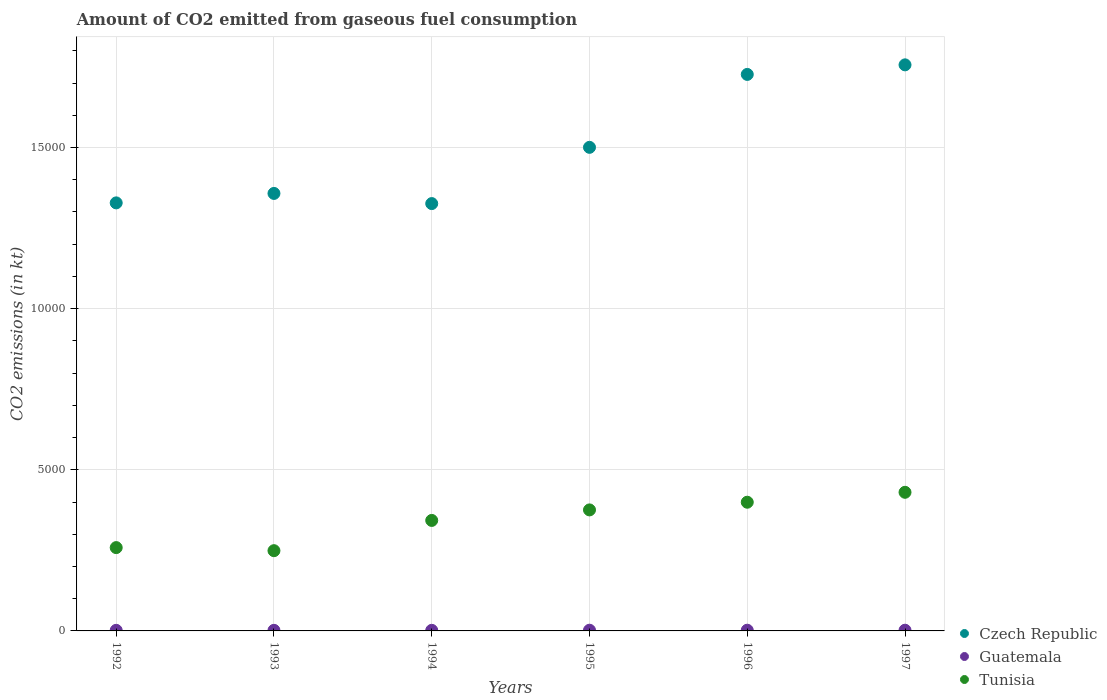How many different coloured dotlines are there?
Give a very brief answer. 3. Is the number of dotlines equal to the number of legend labels?
Your answer should be compact. Yes. What is the amount of CO2 emitted in Czech Republic in 1997?
Give a very brief answer. 1.76e+04. Across all years, what is the maximum amount of CO2 emitted in Guatemala?
Make the answer very short. 22. Across all years, what is the minimum amount of CO2 emitted in Tunisia?
Offer a very short reply. 2489.89. In which year was the amount of CO2 emitted in Czech Republic maximum?
Provide a short and direct response. 1997. In which year was the amount of CO2 emitted in Tunisia minimum?
Keep it short and to the point. 1993. What is the total amount of CO2 emitted in Guatemala in the graph?
Provide a short and direct response. 121.01. What is the difference between the amount of CO2 emitted in Guatemala in 1992 and that in 1995?
Provide a succinct answer. -3.67. What is the difference between the amount of CO2 emitted in Guatemala in 1994 and the amount of CO2 emitted in Czech Republic in 1996?
Offer a very short reply. -1.72e+04. What is the average amount of CO2 emitted in Tunisia per year?
Ensure brevity in your answer.  3425.59. In the year 1995, what is the difference between the amount of CO2 emitted in Guatemala and amount of CO2 emitted in Tunisia?
Provide a short and direct response. -3733.01. What is the ratio of the amount of CO2 emitted in Guatemala in 1992 to that in 1994?
Provide a succinct answer. 1. What is the difference between the highest and the second highest amount of CO2 emitted in Czech Republic?
Provide a short and direct response. 297.03. What is the difference between the highest and the lowest amount of CO2 emitted in Guatemala?
Keep it short and to the point. 3.67. In how many years, is the amount of CO2 emitted in Czech Republic greater than the average amount of CO2 emitted in Czech Republic taken over all years?
Provide a succinct answer. 3. Is it the case that in every year, the sum of the amount of CO2 emitted in Tunisia and amount of CO2 emitted in Guatemala  is greater than the amount of CO2 emitted in Czech Republic?
Your answer should be very brief. No. How many dotlines are there?
Your response must be concise. 3. Does the graph contain grids?
Your response must be concise. Yes. Where does the legend appear in the graph?
Provide a short and direct response. Bottom right. How are the legend labels stacked?
Keep it short and to the point. Vertical. What is the title of the graph?
Provide a short and direct response. Amount of CO2 emitted from gaseous fuel consumption. Does "Thailand" appear as one of the legend labels in the graph?
Your answer should be very brief. No. What is the label or title of the X-axis?
Ensure brevity in your answer.  Years. What is the label or title of the Y-axis?
Make the answer very short. CO2 emissions (in kt). What is the CO2 emissions (in kt) of Czech Republic in 1992?
Offer a terse response. 1.33e+04. What is the CO2 emissions (in kt) of Guatemala in 1992?
Give a very brief answer. 18.34. What is the CO2 emissions (in kt) in Tunisia in 1992?
Your answer should be compact. 2585.24. What is the CO2 emissions (in kt) in Czech Republic in 1993?
Your answer should be compact. 1.36e+04. What is the CO2 emissions (in kt) of Guatemala in 1993?
Give a very brief answer. 18.34. What is the CO2 emissions (in kt) of Tunisia in 1993?
Give a very brief answer. 2489.89. What is the CO2 emissions (in kt) of Czech Republic in 1994?
Your answer should be compact. 1.33e+04. What is the CO2 emissions (in kt) of Guatemala in 1994?
Your answer should be compact. 18.34. What is the CO2 emissions (in kt) of Tunisia in 1994?
Provide a succinct answer. 3428.64. What is the CO2 emissions (in kt) of Czech Republic in 1995?
Your answer should be very brief. 1.50e+04. What is the CO2 emissions (in kt) of Guatemala in 1995?
Provide a short and direct response. 22. What is the CO2 emissions (in kt) in Tunisia in 1995?
Provide a short and direct response. 3755.01. What is the CO2 emissions (in kt) in Czech Republic in 1996?
Provide a succinct answer. 1.73e+04. What is the CO2 emissions (in kt) in Guatemala in 1996?
Make the answer very short. 22. What is the CO2 emissions (in kt) of Tunisia in 1996?
Your answer should be very brief. 3993.36. What is the CO2 emissions (in kt) of Czech Republic in 1997?
Provide a succinct answer. 1.76e+04. What is the CO2 emissions (in kt) in Guatemala in 1997?
Provide a short and direct response. 22. What is the CO2 emissions (in kt) in Tunisia in 1997?
Provide a succinct answer. 4301.39. Across all years, what is the maximum CO2 emissions (in kt) in Czech Republic?
Provide a succinct answer. 1.76e+04. Across all years, what is the maximum CO2 emissions (in kt) in Guatemala?
Offer a very short reply. 22. Across all years, what is the maximum CO2 emissions (in kt) in Tunisia?
Provide a succinct answer. 4301.39. Across all years, what is the minimum CO2 emissions (in kt) in Czech Republic?
Your answer should be compact. 1.33e+04. Across all years, what is the minimum CO2 emissions (in kt) in Guatemala?
Make the answer very short. 18.34. Across all years, what is the minimum CO2 emissions (in kt) of Tunisia?
Your response must be concise. 2489.89. What is the total CO2 emissions (in kt) in Czech Republic in the graph?
Provide a succinct answer. 9.00e+04. What is the total CO2 emissions (in kt) in Guatemala in the graph?
Keep it short and to the point. 121.01. What is the total CO2 emissions (in kt) of Tunisia in the graph?
Ensure brevity in your answer.  2.06e+04. What is the difference between the CO2 emissions (in kt) of Czech Republic in 1992 and that in 1993?
Your response must be concise. -293.36. What is the difference between the CO2 emissions (in kt) of Guatemala in 1992 and that in 1993?
Offer a terse response. 0. What is the difference between the CO2 emissions (in kt) in Tunisia in 1992 and that in 1993?
Offer a terse response. 95.34. What is the difference between the CO2 emissions (in kt) in Czech Republic in 1992 and that in 1994?
Provide a succinct answer. 22. What is the difference between the CO2 emissions (in kt) of Guatemala in 1992 and that in 1994?
Provide a short and direct response. 0. What is the difference between the CO2 emissions (in kt) of Tunisia in 1992 and that in 1994?
Make the answer very short. -843.41. What is the difference between the CO2 emissions (in kt) in Czech Republic in 1992 and that in 1995?
Your answer should be compact. -1723.49. What is the difference between the CO2 emissions (in kt) in Guatemala in 1992 and that in 1995?
Offer a very short reply. -3.67. What is the difference between the CO2 emissions (in kt) in Tunisia in 1992 and that in 1995?
Provide a short and direct response. -1169.77. What is the difference between the CO2 emissions (in kt) in Czech Republic in 1992 and that in 1996?
Keep it short and to the point. -3986.03. What is the difference between the CO2 emissions (in kt) of Guatemala in 1992 and that in 1996?
Provide a short and direct response. -3.67. What is the difference between the CO2 emissions (in kt) of Tunisia in 1992 and that in 1996?
Your answer should be compact. -1408.13. What is the difference between the CO2 emissions (in kt) of Czech Republic in 1992 and that in 1997?
Offer a very short reply. -4283.06. What is the difference between the CO2 emissions (in kt) of Guatemala in 1992 and that in 1997?
Make the answer very short. -3.67. What is the difference between the CO2 emissions (in kt) in Tunisia in 1992 and that in 1997?
Ensure brevity in your answer.  -1716.16. What is the difference between the CO2 emissions (in kt) of Czech Republic in 1993 and that in 1994?
Offer a very short reply. 315.36. What is the difference between the CO2 emissions (in kt) of Tunisia in 1993 and that in 1994?
Provide a succinct answer. -938.75. What is the difference between the CO2 emissions (in kt) in Czech Republic in 1993 and that in 1995?
Provide a short and direct response. -1430.13. What is the difference between the CO2 emissions (in kt) in Guatemala in 1993 and that in 1995?
Make the answer very short. -3.67. What is the difference between the CO2 emissions (in kt) in Tunisia in 1993 and that in 1995?
Your response must be concise. -1265.12. What is the difference between the CO2 emissions (in kt) of Czech Republic in 1993 and that in 1996?
Offer a terse response. -3692.67. What is the difference between the CO2 emissions (in kt) of Guatemala in 1993 and that in 1996?
Your answer should be compact. -3.67. What is the difference between the CO2 emissions (in kt) in Tunisia in 1993 and that in 1996?
Your answer should be very brief. -1503.47. What is the difference between the CO2 emissions (in kt) in Czech Republic in 1993 and that in 1997?
Provide a short and direct response. -3989.7. What is the difference between the CO2 emissions (in kt) of Guatemala in 1993 and that in 1997?
Ensure brevity in your answer.  -3.67. What is the difference between the CO2 emissions (in kt) of Tunisia in 1993 and that in 1997?
Keep it short and to the point. -1811.5. What is the difference between the CO2 emissions (in kt) in Czech Republic in 1994 and that in 1995?
Your answer should be compact. -1745.49. What is the difference between the CO2 emissions (in kt) in Guatemala in 1994 and that in 1995?
Keep it short and to the point. -3.67. What is the difference between the CO2 emissions (in kt) of Tunisia in 1994 and that in 1995?
Offer a very short reply. -326.36. What is the difference between the CO2 emissions (in kt) of Czech Republic in 1994 and that in 1996?
Your response must be concise. -4008.03. What is the difference between the CO2 emissions (in kt) in Guatemala in 1994 and that in 1996?
Keep it short and to the point. -3.67. What is the difference between the CO2 emissions (in kt) of Tunisia in 1994 and that in 1996?
Provide a succinct answer. -564.72. What is the difference between the CO2 emissions (in kt) of Czech Republic in 1994 and that in 1997?
Provide a succinct answer. -4305.06. What is the difference between the CO2 emissions (in kt) of Guatemala in 1994 and that in 1997?
Offer a terse response. -3.67. What is the difference between the CO2 emissions (in kt) in Tunisia in 1994 and that in 1997?
Make the answer very short. -872.75. What is the difference between the CO2 emissions (in kt) of Czech Republic in 1995 and that in 1996?
Your answer should be very brief. -2262.54. What is the difference between the CO2 emissions (in kt) of Tunisia in 1995 and that in 1996?
Your response must be concise. -238.35. What is the difference between the CO2 emissions (in kt) of Czech Republic in 1995 and that in 1997?
Your answer should be very brief. -2559.57. What is the difference between the CO2 emissions (in kt) in Tunisia in 1995 and that in 1997?
Ensure brevity in your answer.  -546.38. What is the difference between the CO2 emissions (in kt) in Czech Republic in 1996 and that in 1997?
Make the answer very short. -297.03. What is the difference between the CO2 emissions (in kt) in Tunisia in 1996 and that in 1997?
Your response must be concise. -308.03. What is the difference between the CO2 emissions (in kt) in Czech Republic in 1992 and the CO2 emissions (in kt) in Guatemala in 1993?
Provide a succinct answer. 1.33e+04. What is the difference between the CO2 emissions (in kt) in Czech Republic in 1992 and the CO2 emissions (in kt) in Tunisia in 1993?
Provide a succinct answer. 1.08e+04. What is the difference between the CO2 emissions (in kt) in Guatemala in 1992 and the CO2 emissions (in kt) in Tunisia in 1993?
Your answer should be compact. -2471.56. What is the difference between the CO2 emissions (in kt) in Czech Republic in 1992 and the CO2 emissions (in kt) in Guatemala in 1994?
Give a very brief answer. 1.33e+04. What is the difference between the CO2 emissions (in kt) of Czech Republic in 1992 and the CO2 emissions (in kt) of Tunisia in 1994?
Keep it short and to the point. 9853.23. What is the difference between the CO2 emissions (in kt) in Guatemala in 1992 and the CO2 emissions (in kt) in Tunisia in 1994?
Your answer should be very brief. -3410.31. What is the difference between the CO2 emissions (in kt) of Czech Republic in 1992 and the CO2 emissions (in kt) of Guatemala in 1995?
Offer a terse response. 1.33e+04. What is the difference between the CO2 emissions (in kt) of Czech Republic in 1992 and the CO2 emissions (in kt) of Tunisia in 1995?
Provide a short and direct response. 9526.87. What is the difference between the CO2 emissions (in kt) in Guatemala in 1992 and the CO2 emissions (in kt) in Tunisia in 1995?
Provide a succinct answer. -3736.67. What is the difference between the CO2 emissions (in kt) of Czech Republic in 1992 and the CO2 emissions (in kt) of Guatemala in 1996?
Ensure brevity in your answer.  1.33e+04. What is the difference between the CO2 emissions (in kt) in Czech Republic in 1992 and the CO2 emissions (in kt) in Tunisia in 1996?
Your answer should be compact. 9288.51. What is the difference between the CO2 emissions (in kt) in Guatemala in 1992 and the CO2 emissions (in kt) in Tunisia in 1996?
Your answer should be compact. -3975.03. What is the difference between the CO2 emissions (in kt) in Czech Republic in 1992 and the CO2 emissions (in kt) in Guatemala in 1997?
Provide a short and direct response. 1.33e+04. What is the difference between the CO2 emissions (in kt) in Czech Republic in 1992 and the CO2 emissions (in kt) in Tunisia in 1997?
Your answer should be compact. 8980.48. What is the difference between the CO2 emissions (in kt) of Guatemala in 1992 and the CO2 emissions (in kt) of Tunisia in 1997?
Your answer should be compact. -4283.06. What is the difference between the CO2 emissions (in kt) in Czech Republic in 1993 and the CO2 emissions (in kt) in Guatemala in 1994?
Make the answer very short. 1.36e+04. What is the difference between the CO2 emissions (in kt) of Czech Republic in 1993 and the CO2 emissions (in kt) of Tunisia in 1994?
Offer a very short reply. 1.01e+04. What is the difference between the CO2 emissions (in kt) in Guatemala in 1993 and the CO2 emissions (in kt) in Tunisia in 1994?
Offer a terse response. -3410.31. What is the difference between the CO2 emissions (in kt) of Czech Republic in 1993 and the CO2 emissions (in kt) of Guatemala in 1995?
Provide a short and direct response. 1.36e+04. What is the difference between the CO2 emissions (in kt) in Czech Republic in 1993 and the CO2 emissions (in kt) in Tunisia in 1995?
Ensure brevity in your answer.  9820.23. What is the difference between the CO2 emissions (in kt) in Guatemala in 1993 and the CO2 emissions (in kt) in Tunisia in 1995?
Give a very brief answer. -3736.67. What is the difference between the CO2 emissions (in kt) of Czech Republic in 1993 and the CO2 emissions (in kt) of Guatemala in 1996?
Your answer should be very brief. 1.36e+04. What is the difference between the CO2 emissions (in kt) of Czech Republic in 1993 and the CO2 emissions (in kt) of Tunisia in 1996?
Make the answer very short. 9581.87. What is the difference between the CO2 emissions (in kt) of Guatemala in 1993 and the CO2 emissions (in kt) of Tunisia in 1996?
Ensure brevity in your answer.  -3975.03. What is the difference between the CO2 emissions (in kt) of Czech Republic in 1993 and the CO2 emissions (in kt) of Guatemala in 1997?
Keep it short and to the point. 1.36e+04. What is the difference between the CO2 emissions (in kt) of Czech Republic in 1993 and the CO2 emissions (in kt) of Tunisia in 1997?
Keep it short and to the point. 9273.84. What is the difference between the CO2 emissions (in kt) in Guatemala in 1993 and the CO2 emissions (in kt) in Tunisia in 1997?
Provide a short and direct response. -4283.06. What is the difference between the CO2 emissions (in kt) in Czech Republic in 1994 and the CO2 emissions (in kt) in Guatemala in 1995?
Offer a very short reply. 1.32e+04. What is the difference between the CO2 emissions (in kt) of Czech Republic in 1994 and the CO2 emissions (in kt) of Tunisia in 1995?
Offer a very short reply. 9504.86. What is the difference between the CO2 emissions (in kt) of Guatemala in 1994 and the CO2 emissions (in kt) of Tunisia in 1995?
Your response must be concise. -3736.67. What is the difference between the CO2 emissions (in kt) of Czech Republic in 1994 and the CO2 emissions (in kt) of Guatemala in 1996?
Your answer should be compact. 1.32e+04. What is the difference between the CO2 emissions (in kt) of Czech Republic in 1994 and the CO2 emissions (in kt) of Tunisia in 1996?
Ensure brevity in your answer.  9266.51. What is the difference between the CO2 emissions (in kt) of Guatemala in 1994 and the CO2 emissions (in kt) of Tunisia in 1996?
Ensure brevity in your answer.  -3975.03. What is the difference between the CO2 emissions (in kt) in Czech Republic in 1994 and the CO2 emissions (in kt) in Guatemala in 1997?
Ensure brevity in your answer.  1.32e+04. What is the difference between the CO2 emissions (in kt) in Czech Republic in 1994 and the CO2 emissions (in kt) in Tunisia in 1997?
Provide a succinct answer. 8958.48. What is the difference between the CO2 emissions (in kt) of Guatemala in 1994 and the CO2 emissions (in kt) of Tunisia in 1997?
Ensure brevity in your answer.  -4283.06. What is the difference between the CO2 emissions (in kt) in Czech Republic in 1995 and the CO2 emissions (in kt) in Guatemala in 1996?
Your answer should be compact. 1.50e+04. What is the difference between the CO2 emissions (in kt) of Czech Republic in 1995 and the CO2 emissions (in kt) of Tunisia in 1996?
Your response must be concise. 1.10e+04. What is the difference between the CO2 emissions (in kt) in Guatemala in 1995 and the CO2 emissions (in kt) in Tunisia in 1996?
Your answer should be compact. -3971.36. What is the difference between the CO2 emissions (in kt) in Czech Republic in 1995 and the CO2 emissions (in kt) in Guatemala in 1997?
Make the answer very short. 1.50e+04. What is the difference between the CO2 emissions (in kt) of Czech Republic in 1995 and the CO2 emissions (in kt) of Tunisia in 1997?
Give a very brief answer. 1.07e+04. What is the difference between the CO2 emissions (in kt) of Guatemala in 1995 and the CO2 emissions (in kt) of Tunisia in 1997?
Offer a terse response. -4279.39. What is the difference between the CO2 emissions (in kt) of Czech Republic in 1996 and the CO2 emissions (in kt) of Guatemala in 1997?
Your answer should be compact. 1.72e+04. What is the difference between the CO2 emissions (in kt) of Czech Republic in 1996 and the CO2 emissions (in kt) of Tunisia in 1997?
Make the answer very short. 1.30e+04. What is the difference between the CO2 emissions (in kt) of Guatemala in 1996 and the CO2 emissions (in kt) of Tunisia in 1997?
Your answer should be very brief. -4279.39. What is the average CO2 emissions (in kt) in Czech Republic per year?
Provide a succinct answer. 1.50e+04. What is the average CO2 emissions (in kt) in Guatemala per year?
Keep it short and to the point. 20.17. What is the average CO2 emissions (in kt) in Tunisia per year?
Offer a terse response. 3425.59. In the year 1992, what is the difference between the CO2 emissions (in kt) in Czech Republic and CO2 emissions (in kt) in Guatemala?
Offer a very short reply. 1.33e+04. In the year 1992, what is the difference between the CO2 emissions (in kt) in Czech Republic and CO2 emissions (in kt) in Tunisia?
Your answer should be compact. 1.07e+04. In the year 1992, what is the difference between the CO2 emissions (in kt) in Guatemala and CO2 emissions (in kt) in Tunisia?
Keep it short and to the point. -2566.9. In the year 1993, what is the difference between the CO2 emissions (in kt) of Czech Republic and CO2 emissions (in kt) of Guatemala?
Give a very brief answer. 1.36e+04. In the year 1993, what is the difference between the CO2 emissions (in kt) in Czech Republic and CO2 emissions (in kt) in Tunisia?
Offer a very short reply. 1.11e+04. In the year 1993, what is the difference between the CO2 emissions (in kt) of Guatemala and CO2 emissions (in kt) of Tunisia?
Offer a very short reply. -2471.56. In the year 1994, what is the difference between the CO2 emissions (in kt) of Czech Republic and CO2 emissions (in kt) of Guatemala?
Keep it short and to the point. 1.32e+04. In the year 1994, what is the difference between the CO2 emissions (in kt) in Czech Republic and CO2 emissions (in kt) in Tunisia?
Your answer should be very brief. 9831.23. In the year 1994, what is the difference between the CO2 emissions (in kt) in Guatemala and CO2 emissions (in kt) in Tunisia?
Offer a terse response. -3410.31. In the year 1995, what is the difference between the CO2 emissions (in kt) in Czech Republic and CO2 emissions (in kt) in Guatemala?
Your response must be concise. 1.50e+04. In the year 1995, what is the difference between the CO2 emissions (in kt) in Czech Republic and CO2 emissions (in kt) in Tunisia?
Offer a terse response. 1.13e+04. In the year 1995, what is the difference between the CO2 emissions (in kt) of Guatemala and CO2 emissions (in kt) of Tunisia?
Keep it short and to the point. -3733.01. In the year 1996, what is the difference between the CO2 emissions (in kt) in Czech Republic and CO2 emissions (in kt) in Guatemala?
Provide a succinct answer. 1.72e+04. In the year 1996, what is the difference between the CO2 emissions (in kt) in Czech Republic and CO2 emissions (in kt) in Tunisia?
Provide a succinct answer. 1.33e+04. In the year 1996, what is the difference between the CO2 emissions (in kt) in Guatemala and CO2 emissions (in kt) in Tunisia?
Keep it short and to the point. -3971.36. In the year 1997, what is the difference between the CO2 emissions (in kt) in Czech Republic and CO2 emissions (in kt) in Guatemala?
Offer a terse response. 1.75e+04. In the year 1997, what is the difference between the CO2 emissions (in kt) of Czech Republic and CO2 emissions (in kt) of Tunisia?
Give a very brief answer. 1.33e+04. In the year 1997, what is the difference between the CO2 emissions (in kt) of Guatemala and CO2 emissions (in kt) of Tunisia?
Provide a short and direct response. -4279.39. What is the ratio of the CO2 emissions (in kt) of Czech Republic in 1992 to that in 1993?
Your answer should be very brief. 0.98. What is the ratio of the CO2 emissions (in kt) in Tunisia in 1992 to that in 1993?
Provide a short and direct response. 1.04. What is the ratio of the CO2 emissions (in kt) in Tunisia in 1992 to that in 1994?
Your answer should be very brief. 0.75. What is the ratio of the CO2 emissions (in kt) in Czech Republic in 1992 to that in 1995?
Provide a succinct answer. 0.89. What is the ratio of the CO2 emissions (in kt) in Tunisia in 1992 to that in 1995?
Offer a very short reply. 0.69. What is the ratio of the CO2 emissions (in kt) of Czech Republic in 1992 to that in 1996?
Give a very brief answer. 0.77. What is the ratio of the CO2 emissions (in kt) of Tunisia in 1992 to that in 1996?
Provide a short and direct response. 0.65. What is the ratio of the CO2 emissions (in kt) in Czech Republic in 1992 to that in 1997?
Your answer should be very brief. 0.76. What is the ratio of the CO2 emissions (in kt) in Guatemala in 1992 to that in 1997?
Offer a very short reply. 0.83. What is the ratio of the CO2 emissions (in kt) of Tunisia in 1992 to that in 1997?
Make the answer very short. 0.6. What is the ratio of the CO2 emissions (in kt) in Czech Republic in 1993 to that in 1994?
Keep it short and to the point. 1.02. What is the ratio of the CO2 emissions (in kt) of Guatemala in 1993 to that in 1994?
Make the answer very short. 1. What is the ratio of the CO2 emissions (in kt) in Tunisia in 1993 to that in 1994?
Give a very brief answer. 0.73. What is the ratio of the CO2 emissions (in kt) of Czech Republic in 1993 to that in 1995?
Make the answer very short. 0.9. What is the ratio of the CO2 emissions (in kt) in Guatemala in 1993 to that in 1995?
Give a very brief answer. 0.83. What is the ratio of the CO2 emissions (in kt) of Tunisia in 1993 to that in 1995?
Make the answer very short. 0.66. What is the ratio of the CO2 emissions (in kt) in Czech Republic in 1993 to that in 1996?
Keep it short and to the point. 0.79. What is the ratio of the CO2 emissions (in kt) of Tunisia in 1993 to that in 1996?
Your answer should be very brief. 0.62. What is the ratio of the CO2 emissions (in kt) of Czech Republic in 1993 to that in 1997?
Keep it short and to the point. 0.77. What is the ratio of the CO2 emissions (in kt) of Guatemala in 1993 to that in 1997?
Your response must be concise. 0.83. What is the ratio of the CO2 emissions (in kt) of Tunisia in 1993 to that in 1997?
Provide a short and direct response. 0.58. What is the ratio of the CO2 emissions (in kt) of Czech Republic in 1994 to that in 1995?
Your response must be concise. 0.88. What is the ratio of the CO2 emissions (in kt) in Tunisia in 1994 to that in 1995?
Offer a very short reply. 0.91. What is the ratio of the CO2 emissions (in kt) in Czech Republic in 1994 to that in 1996?
Offer a terse response. 0.77. What is the ratio of the CO2 emissions (in kt) of Tunisia in 1994 to that in 1996?
Provide a short and direct response. 0.86. What is the ratio of the CO2 emissions (in kt) in Czech Republic in 1994 to that in 1997?
Offer a terse response. 0.75. What is the ratio of the CO2 emissions (in kt) in Tunisia in 1994 to that in 1997?
Your answer should be compact. 0.8. What is the ratio of the CO2 emissions (in kt) of Czech Republic in 1995 to that in 1996?
Provide a short and direct response. 0.87. What is the ratio of the CO2 emissions (in kt) of Guatemala in 1995 to that in 1996?
Offer a terse response. 1. What is the ratio of the CO2 emissions (in kt) of Tunisia in 1995 to that in 1996?
Offer a terse response. 0.94. What is the ratio of the CO2 emissions (in kt) in Czech Republic in 1995 to that in 1997?
Provide a short and direct response. 0.85. What is the ratio of the CO2 emissions (in kt) of Guatemala in 1995 to that in 1997?
Your answer should be very brief. 1. What is the ratio of the CO2 emissions (in kt) in Tunisia in 1995 to that in 1997?
Ensure brevity in your answer.  0.87. What is the ratio of the CO2 emissions (in kt) of Czech Republic in 1996 to that in 1997?
Ensure brevity in your answer.  0.98. What is the ratio of the CO2 emissions (in kt) of Guatemala in 1996 to that in 1997?
Your answer should be compact. 1. What is the ratio of the CO2 emissions (in kt) of Tunisia in 1996 to that in 1997?
Provide a succinct answer. 0.93. What is the difference between the highest and the second highest CO2 emissions (in kt) of Czech Republic?
Provide a succinct answer. 297.03. What is the difference between the highest and the second highest CO2 emissions (in kt) of Tunisia?
Provide a succinct answer. 308.03. What is the difference between the highest and the lowest CO2 emissions (in kt) of Czech Republic?
Your answer should be compact. 4305.06. What is the difference between the highest and the lowest CO2 emissions (in kt) in Guatemala?
Provide a succinct answer. 3.67. What is the difference between the highest and the lowest CO2 emissions (in kt) of Tunisia?
Your answer should be very brief. 1811.5. 